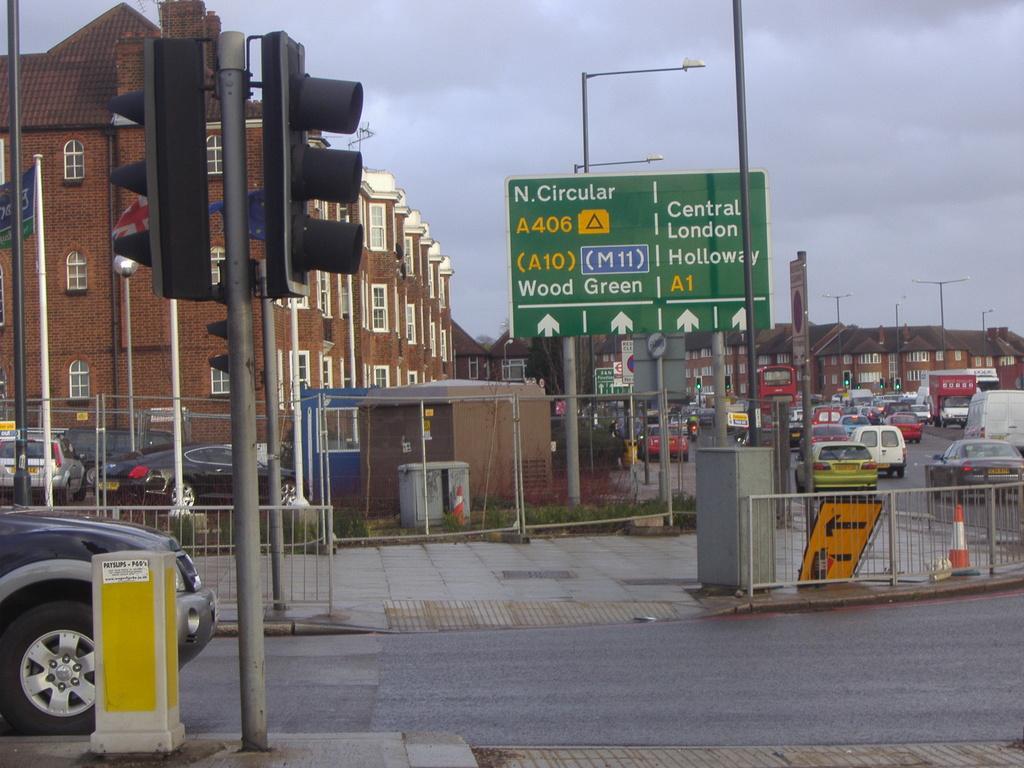Can you describe this image briefly? In this image we can see some buildings with windows and some vehicles on the road. We can also see the metal fence, traffic poles, a board, containers, grass, street poles, the sign boards with some text on them, the traffic signal, the flags to the poles and the sky which looks cloudy. 